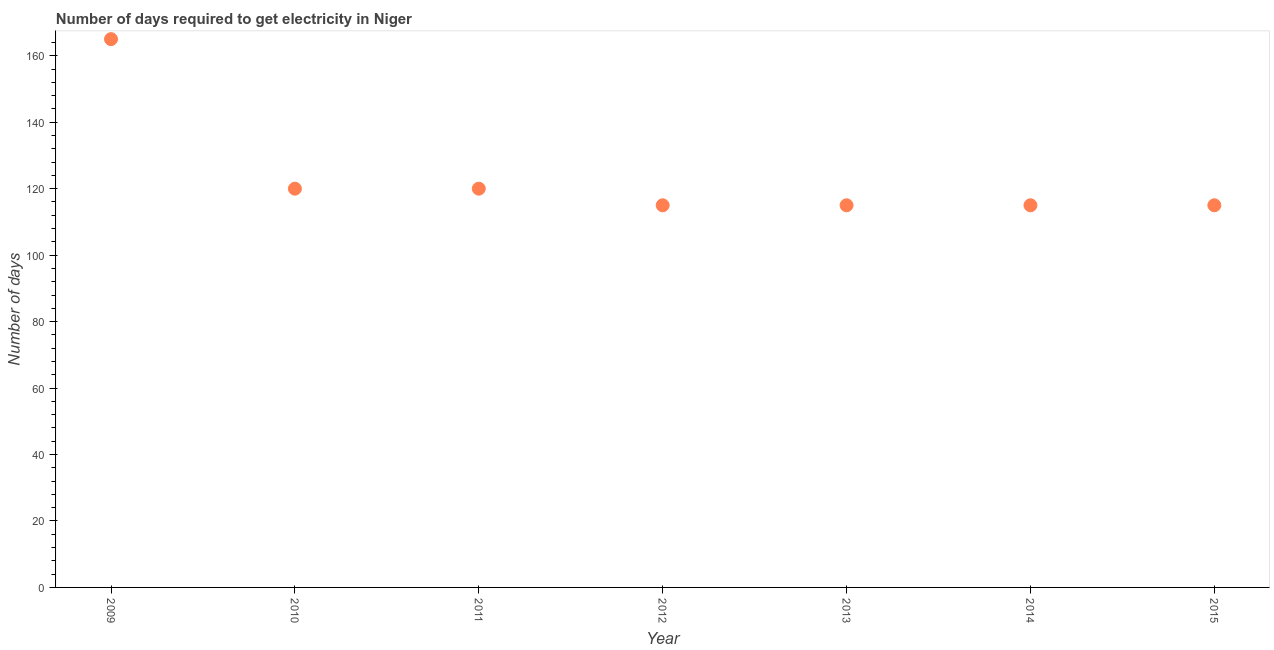What is the time to get electricity in 2009?
Keep it short and to the point. 165. Across all years, what is the maximum time to get electricity?
Provide a short and direct response. 165. Across all years, what is the minimum time to get electricity?
Offer a very short reply. 115. What is the sum of the time to get electricity?
Your response must be concise. 865. What is the difference between the time to get electricity in 2009 and 2013?
Provide a succinct answer. 50. What is the average time to get electricity per year?
Your answer should be compact. 123.57. What is the median time to get electricity?
Provide a short and direct response. 115. Do a majority of the years between 2014 and 2013 (inclusive) have time to get electricity greater than 4 ?
Your answer should be very brief. No. What is the ratio of the time to get electricity in 2009 to that in 2015?
Ensure brevity in your answer.  1.43. What is the difference between the highest and the second highest time to get electricity?
Make the answer very short. 45. What is the difference between the highest and the lowest time to get electricity?
Offer a very short reply. 50. In how many years, is the time to get electricity greater than the average time to get electricity taken over all years?
Provide a short and direct response. 1. How many years are there in the graph?
Provide a succinct answer. 7. What is the difference between two consecutive major ticks on the Y-axis?
Your answer should be compact. 20. Are the values on the major ticks of Y-axis written in scientific E-notation?
Keep it short and to the point. No. Does the graph contain any zero values?
Keep it short and to the point. No. What is the title of the graph?
Offer a terse response. Number of days required to get electricity in Niger. What is the label or title of the X-axis?
Offer a very short reply. Year. What is the label or title of the Y-axis?
Ensure brevity in your answer.  Number of days. What is the Number of days in 2009?
Offer a terse response. 165. What is the Number of days in 2010?
Provide a succinct answer. 120. What is the Number of days in 2011?
Offer a terse response. 120. What is the Number of days in 2012?
Ensure brevity in your answer.  115. What is the Number of days in 2013?
Provide a short and direct response. 115. What is the Number of days in 2014?
Ensure brevity in your answer.  115. What is the Number of days in 2015?
Your response must be concise. 115. What is the difference between the Number of days in 2009 and 2010?
Your answer should be very brief. 45. What is the difference between the Number of days in 2009 and 2012?
Ensure brevity in your answer.  50. What is the difference between the Number of days in 2009 and 2013?
Provide a short and direct response. 50. What is the difference between the Number of days in 2009 and 2014?
Provide a short and direct response. 50. What is the difference between the Number of days in 2009 and 2015?
Provide a short and direct response. 50. What is the difference between the Number of days in 2010 and 2012?
Your response must be concise. 5. What is the difference between the Number of days in 2010 and 2013?
Provide a succinct answer. 5. What is the difference between the Number of days in 2010 and 2015?
Make the answer very short. 5. What is the difference between the Number of days in 2011 and 2014?
Offer a terse response. 5. What is the difference between the Number of days in 2011 and 2015?
Give a very brief answer. 5. What is the difference between the Number of days in 2012 and 2014?
Keep it short and to the point. 0. What is the difference between the Number of days in 2013 and 2014?
Provide a succinct answer. 0. What is the difference between the Number of days in 2014 and 2015?
Make the answer very short. 0. What is the ratio of the Number of days in 2009 to that in 2010?
Provide a short and direct response. 1.38. What is the ratio of the Number of days in 2009 to that in 2011?
Ensure brevity in your answer.  1.38. What is the ratio of the Number of days in 2009 to that in 2012?
Offer a very short reply. 1.44. What is the ratio of the Number of days in 2009 to that in 2013?
Ensure brevity in your answer.  1.44. What is the ratio of the Number of days in 2009 to that in 2014?
Keep it short and to the point. 1.44. What is the ratio of the Number of days in 2009 to that in 2015?
Make the answer very short. 1.44. What is the ratio of the Number of days in 2010 to that in 2012?
Offer a terse response. 1.04. What is the ratio of the Number of days in 2010 to that in 2013?
Offer a terse response. 1.04. What is the ratio of the Number of days in 2010 to that in 2014?
Keep it short and to the point. 1.04. What is the ratio of the Number of days in 2010 to that in 2015?
Provide a succinct answer. 1.04. What is the ratio of the Number of days in 2011 to that in 2012?
Your answer should be very brief. 1.04. What is the ratio of the Number of days in 2011 to that in 2013?
Your response must be concise. 1.04. What is the ratio of the Number of days in 2011 to that in 2014?
Keep it short and to the point. 1.04. What is the ratio of the Number of days in 2011 to that in 2015?
Ensure brevity in your answer.  1.04. What is the ratio of the Number of days in 2012 to that in 2015?
Provide a succinct answer. 1. What is the ratio of the Number of days in 2013 to that in 2014?
Provide a succinct answer. 1. What is the ratio of the Number of days in 2013 to that in 2015?
Offer a terse response. 1. 